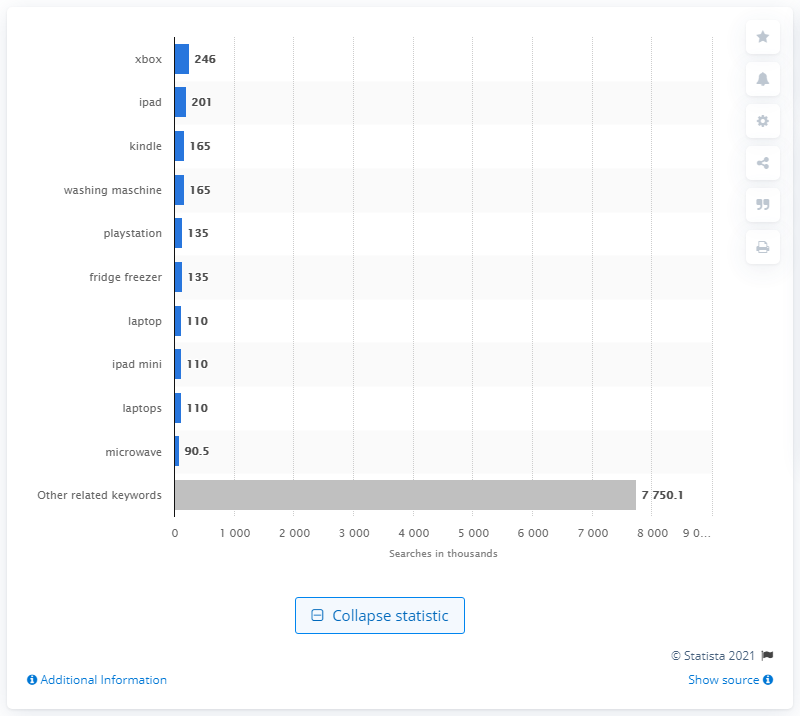Mention a couple of crucial points in this snapshot. In March 2016, the top search query on Google UK was "Xbox. 